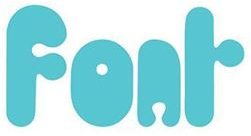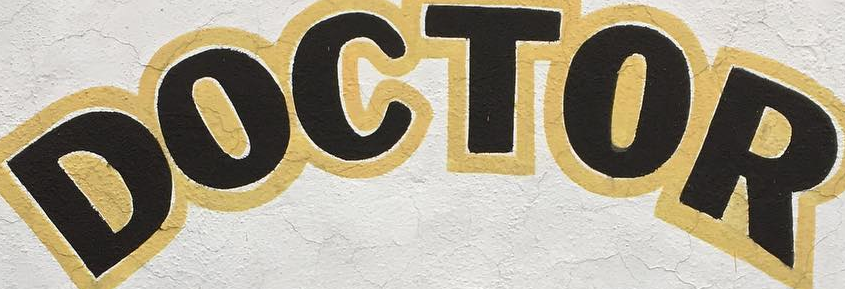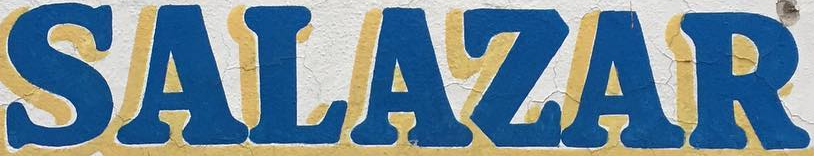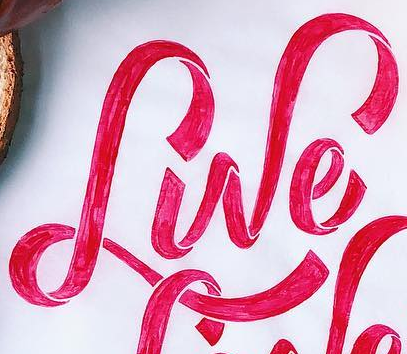What words are shown in these images in order, separated by a semicolon? Fonr; DOCTOR; SALAZAR; Lwe 